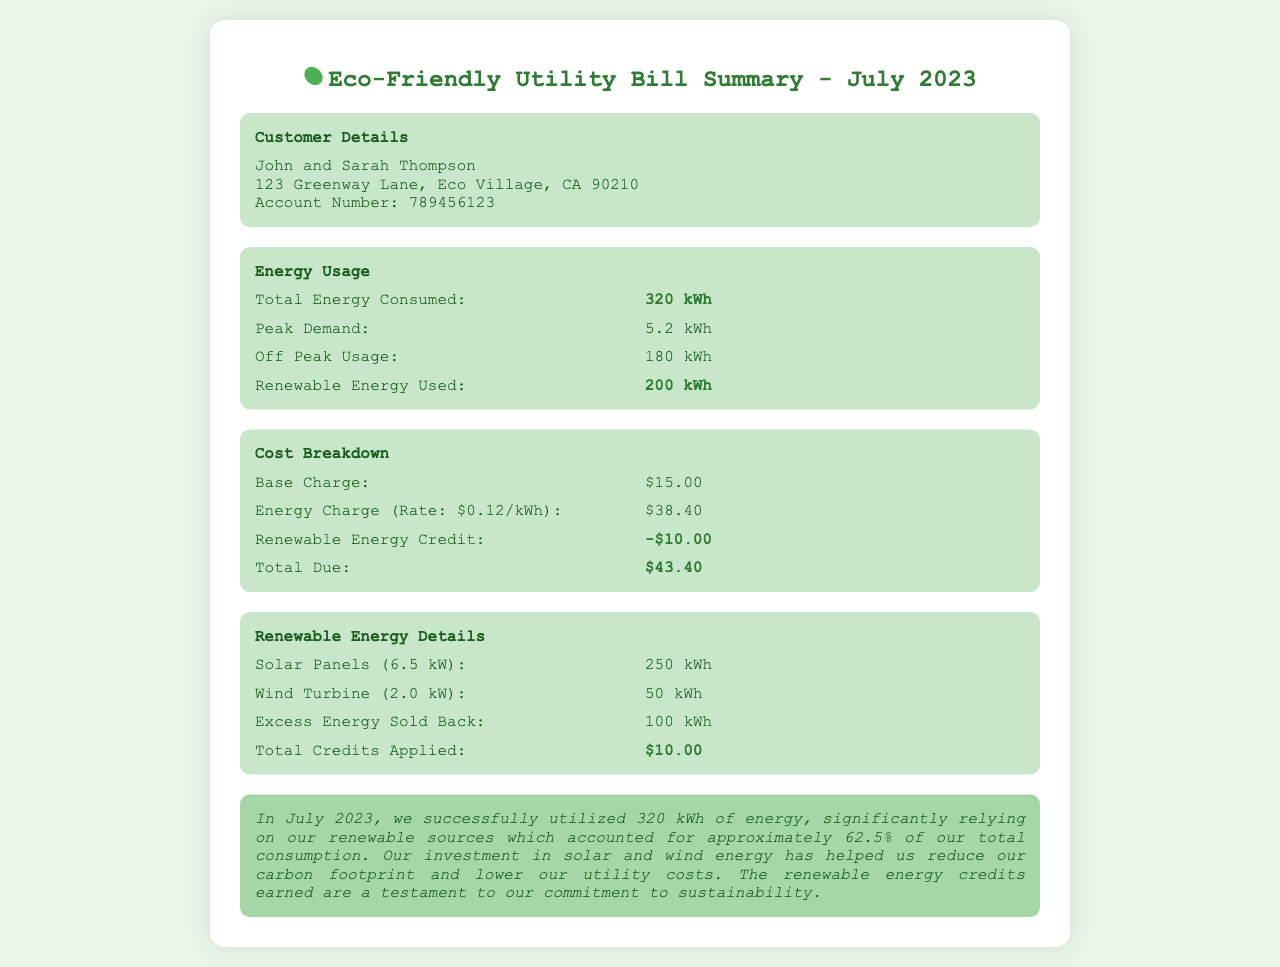What is the total energy consumed? The total energy consumed is stated in the energy usage section of the document as 320 kWh.
Answer: 320 kWh What is the renewable energy used? Renewable energy used is highlighted in the energy usage section and is stated as 200 kWh.
Answer: 200 kWh What is the total due amount? The total due amount is calculated from the cost breakdown and is listed as $43.40.
Answer: $43.40 How much did the base charge cost? The base charge is specified under cost breakdown as $15.00.
Answer: $15.00 What type of renewable energy sources were used? The document mentions solar panels and wind turbines as renewable energy sources.
Answer: Solar panels, Wind turbines What percentage of total consumption did renewable energy account for? The document states approximately 62.5% of total consumption was from renewable energy sources.
Answer: 62.5% How much excess energy was sold back? The excess energy sold back is stated in the renewable energy details as 100 kWh.
Answer: 100 kWh What is the account number? The account number is provided in the customer details section as 789456123.
Answer: 789456123 What is the peak demand recorded? Peak demand is mentioned in the energy usage section as 5.2 kWh.
Answer: 5.2 kWh 